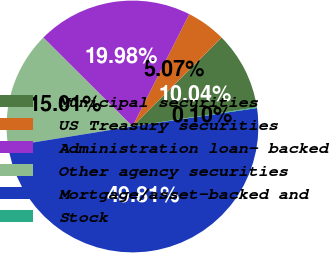Convert chart to OTSL. <chart><loc_0><loc_0><loc_500><loc_500><pie_chart><fcel>Municipal securities<fcel>US Treasury securities<fcel>Administration loan- backed<fcel>Other agency securities<fcel>Mortgage/asset-backed and<fcel>Stock<nl><fcel>10.04%<fcel>5.07%<fcel>19.98%<fcel>15.01%<fcel>49.81%<fcel>0.1%<nl></chart> 